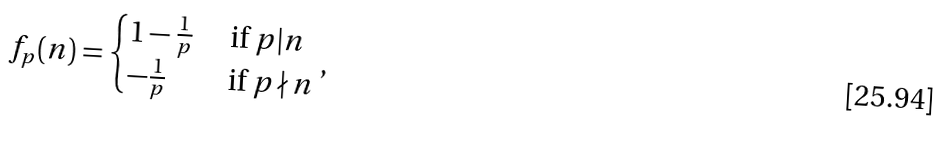Convert formula to latex. <formula><loc_0><loc_0><loc_500><loc_500>f _ { p } ( n ) = \begin{cases} 1 - \frac { 1 } { p } & \text { if } p | n \\ - \frac { 1 } { p } & \text { if } p \nmid n \\ \end{cases} ,</formula> 